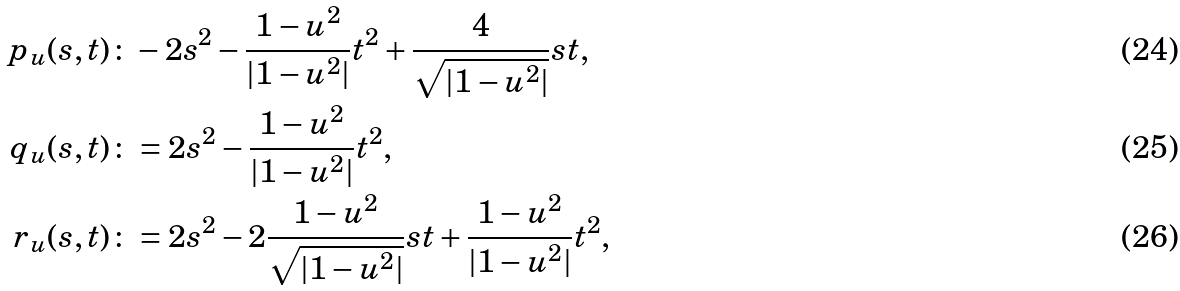<formula> <loc_0><loc_0><loc_500><loc_500>p _ { u } ( s , t ) & \colon - 2 s ^ { 2 } - \frac { 1 - u ^ { 2 } } { | 1 - u ^ { 2 } | } t ^ { 2 } + \frac { 4 } { \sqrt { | 1 - u ^ { 2 } | } } s t , \\ q _ { u } ( s , t ) & \colon = 2 s ^ { 2 } - \frac { 1 - u ^ { 2 } } { | 1 - u ^ { 2 } | } t ^ { 2 } , \\ r _ { u } ( s , t ) & \colon = 2 s ^ { 2 } - 2 \frac { 1 - u ^ { 2 } } { \sqrt { | 1 - u ^ { 2 } | } } s t + \frac { 1 - u ^ { 2 } } { | 1 - u ^ { 2 } | } t ^ { 2 } ,</formula> 